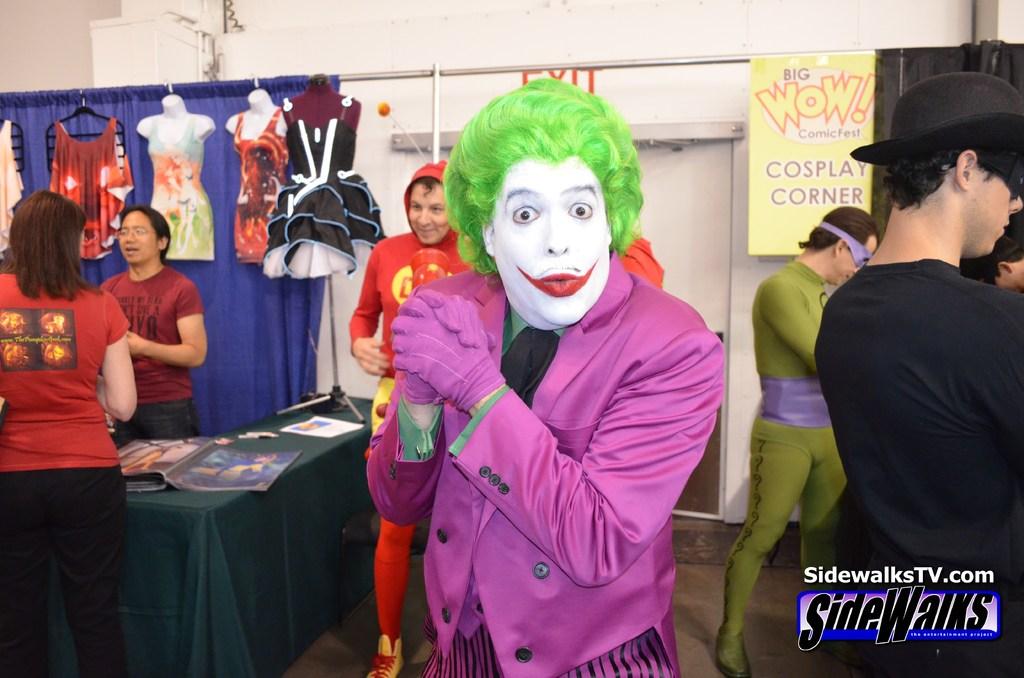What is the website?
Your response must be concise. Sidewalkstv.com. 